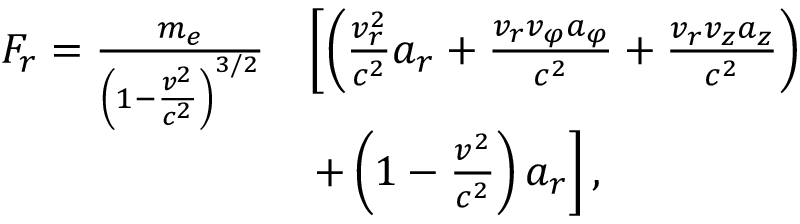Convert formula to latex. <formula><loc_0><loc_0><loc_500><loc_500>\begin{array} { r l } { F _ { r } = \frac { m _ { e } } { \left ( 1 - \frac { v ^ { 2 } } { c ^ { 2 } } \right ) ^ { 3 / 2 } } } & { \left [ \left ( \frac { v _ { r } ^ { 2 } } { c ^ { 2 } } a _ { r } + \frac { v _ { r } v _ { \varphi } a _ { \varphi } } { c ^ { 2 } } + \frac { v _ { r } v _ { z } a _ { z } } { c ^ { 2 } } \right ) } \\ & { + \left ( 1 - \frac { v ^ { 2 } } { c ^ { 2 } } \right ) a _ { r } \right ] , } \end{array}</formula> 